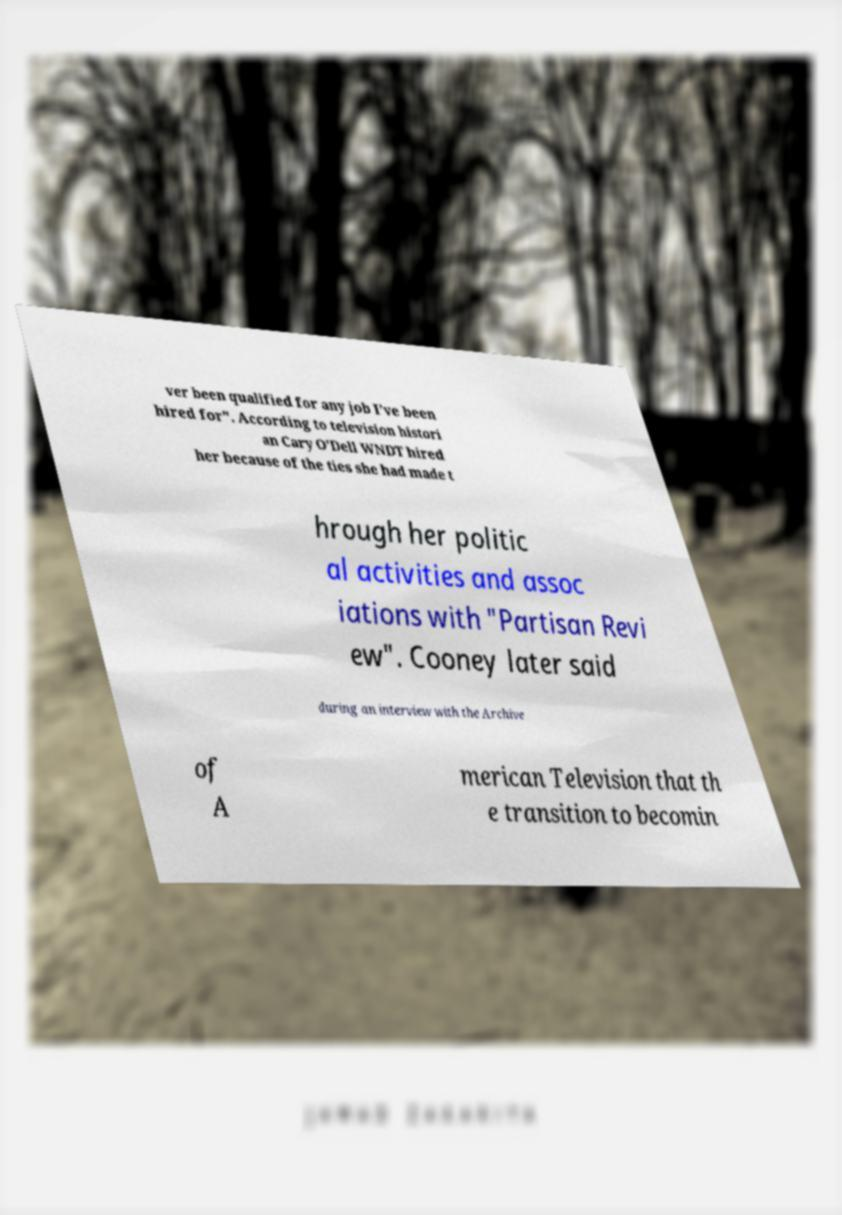Please read and relay the text visible in this image. What does it say? ver been qualified for any job I've been hired for". According to television histori an Cary O'Dell WNDT hired her because of the ties she had made t hrough her politic al activities and assoc iations with "Partisan Revi ew". Cooney later said during an interview with the Archive of A merican Television that th e transition to becomin 